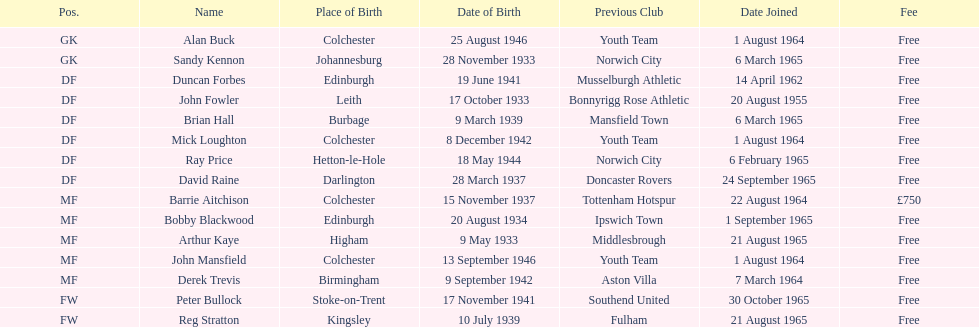What is the date of the first player who joined? 20 August 1955. 